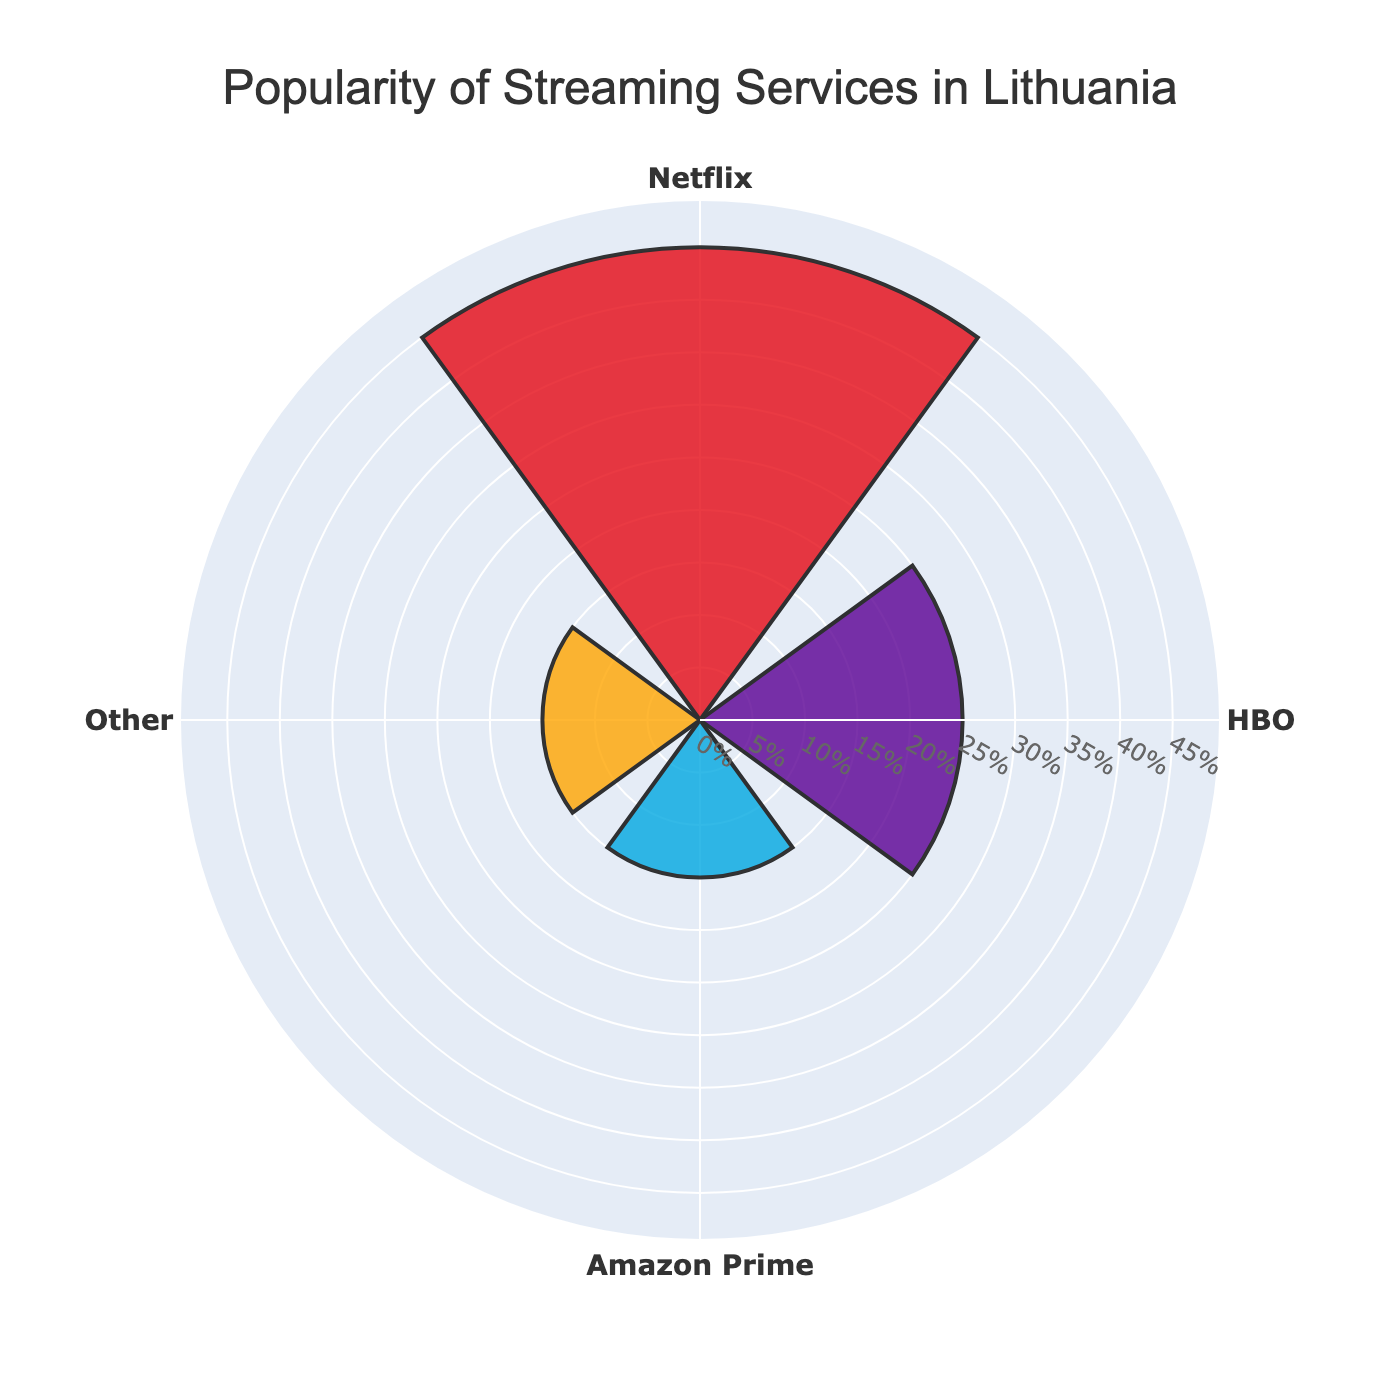What's the title of the chart? The title is displayed at the top of the chart. It reads "Popularity of Streaming Services in Lithuania."
Answer: Popularity of Streaming Services in Lithuania How many streaming services are displayed in the chart? The chart has four different categories. They are "Netflix," "HBO," "Amazon Prime," and an "Other" category.
Answer: Four Which streaming service is the most popular? Looking at the radial bars, Netflix has the longest bar indicating it has the highest popularity percentage.
Answer: Netflix What is the popularity percentage of HBO? The chart shows HBO's bar with a length corresponding to its popularity percentage, which is labeled as 25%.
Answer: 25% How much more popular is Netflix compared to Amazon Prime? Netflix has a popularity percentage of 45%, while Amazon Prime has 15%. The difference is 45% - 15% = 30%.
Answer: 30% What are the colors used to represent Netflix and Amazon Prime in the chart? The bar representing Netflix is red (dark red), while Amazon Prime's bar is blue (light blue).
Answer: Red for Netflix, Blue for Amazon Prime What is the combined popularity percentage of HBO and Amazon Prime? Adding the popularity percentages of HBO (25%) and Amazon Prime (15%) gives us 25% + 15% = 40%.
Answer: 40% Which streaming service other than Netflix is displayed with a color that might remind you of HBO's primary branding? HBO's bar is purple, which aligns with its primary branding color.
Answer: HBO How are the popularity percentages for 'Other' and Amazon Prime related? Both 'Other' and Amazon Prime have the same popularity percentage of 15%.
Answer: They are equal What percentage range is shown on the radial axis of the chart? The radial axis shows a range from 0% to slightly above 45%, considering the maximum value is slightly extended for scaling purposes.
Answer: 0% to slightly above 45% 